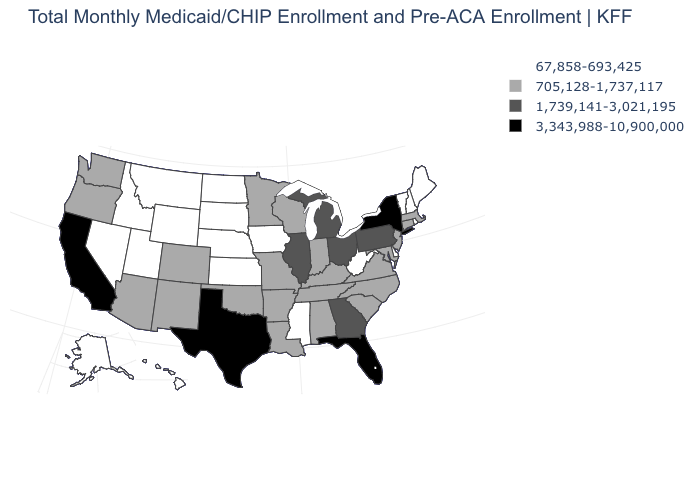Name the states that have a value in the range 67,858-693,425?
Be succinct. Alaska, Delaware, Hawaii, Idaho, Iowa, Kansas, Maine, Mississippi, Montana, Nebraska, Nevada, New Hampshire, North Dakota, Rhode Island, South Dakota, Utah, Vermont, West Virginia, Wyoming. Is the legend a continuous bar?
Quick response, please. No. Which states have the lowest value in the USA?
Keep it brief. Alaska, Delaware, Hawaii, Idaho, Iowa, Kansas, Maine, Mississippi, Montana, Nebraska, Nevada, New Hampshire, North Dakota, Rhode Island, South Dakota, Utah, Vermont, West Virginia, Wyoming. Name the states that have a value in the range 705,128-1,737,117?
Answer briefly. Alabama, Arizona, Arkansas, Colorado, Connecticut, Indiana, Kentucky, Louisiana, Maryland, Massachusetts, Minnesota, Missouri, New Jersey, New Mexico, North Carolina, Oklahoma, Oregon, South Carolina, Tennessee, Virginia, Washington, Wisconsin. Name the states that have a value in the range 1,739,141-3,021,195?
Be succinct. Georgia, Illinois, Michigan, Ohio, Pennsylvania. Does the first symbol in the legend represent the smallest category?
Concise answer only. Yes. How many symbols are there in the legend?
Answer briefly. 4. Among the states that border Missouri , does Illinois have the highest value?
Short answer required. Yes. Among the states that border Illinois , does Iowa have the highest value?
Be succinct. No. Does Florida have the highest value in the USA?
Be succinct. Yes. Name the states that have a value in the range 67,858-693,425?
Be succinct. Alaska, Delaware, Hawaii, Idaho, Iowa, Kansas, Maine, Mississippi, Montana, Nebraska, Nevada, New Hampshire, North Dakota, Rhode Island, South Dakota, Utah, Vermont, West Virginia, Wyoming. What is the value of Missouri?
Concise answer only. 705,128-1,737,117. Among the states that border Indiana , does Kentucky have the highest value?
Give a very brief answer. No. Does the first symbol in the legend represent the smallest category?
Keep it brief. Yes. What is the lowest value in the USA?
Give a very brief answer. 67,858-693,425. 